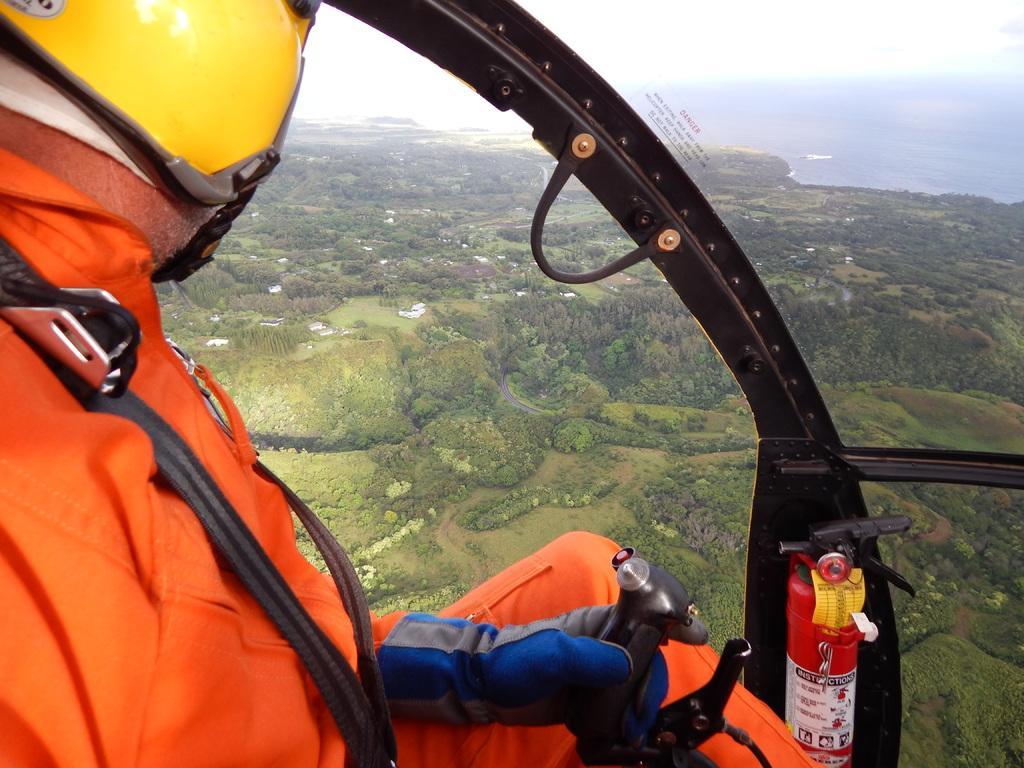Describe this image in one or two sentences. On the left side of the image a person is there. In the background of the image we can see some trees, buildings are there. At the top of the image sky is there. On the right side of the image fire extinguisher is there. 